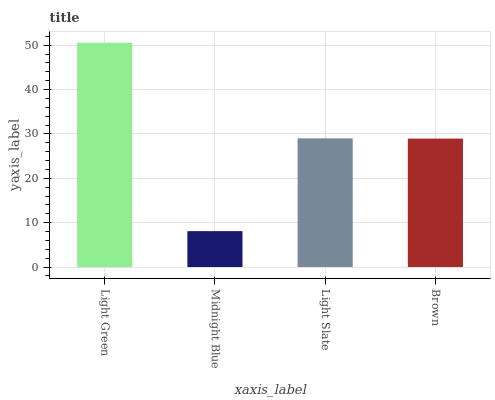Is Midnight Blue the minimum?
Answer yes or no. Yes. Is Light Green the maximum?
Answer yes or no. Yes. Is Light Slate the minimum?
Answer yes or no. No. Is Light Slate the maximum?
Answer yes or no. No. Is Light Slate greater than Midnight Blue?
Answer yes or no. Yes. Is Midnight Blue less than Light Slate?
Answer yes or no. Yes. Is Midnight Blue greater than Light Slate?
Answer yes or no. No. Is Light Slate less than Midnight Blue?
Answer yes or no. No. Is Light Slate the high median?
Answer yes or no. Yes. Is Brown the low median?
Answer yes or no. Yes. Is Midnight Blue the high median?
Answer yes or no. No. Is Light Green the low median?
Answer yes or no. No. 